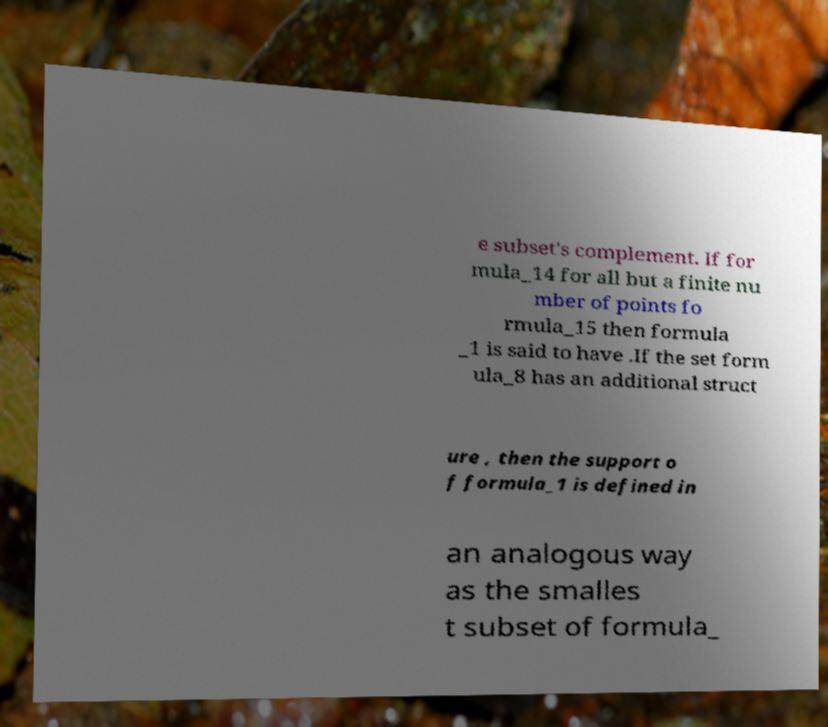There's text embedded in this image that I need extracted. Can you transcribe it verbatim? e subset's complement. If for mula_14 for all but a finite nu mber of points fo rmula_15 then formula _1 is said to have .If the set form ula_8 has an additional struct ure , then the support o f formula_1 is defined in an analogous way as the smalles t subset of formula_ 